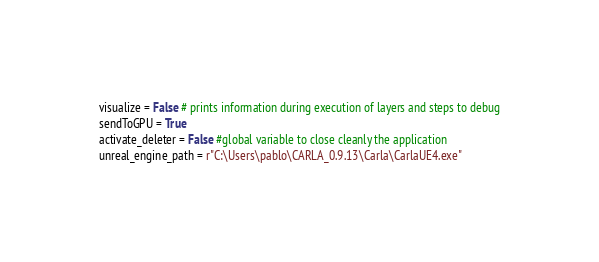Convert code to text. <code><loc_0><loc_0><loc_500><loc_500><_Python_>visualize = False # prints information during execution of layers and steps to debug
sendToGPU = True
activate_deleter = False #global variable to close cleanly the application
unreal_engine_path = r"C:\Users\pablo\CARLA_0.9.13\Carla\CarlaUE4.exe"</code> 